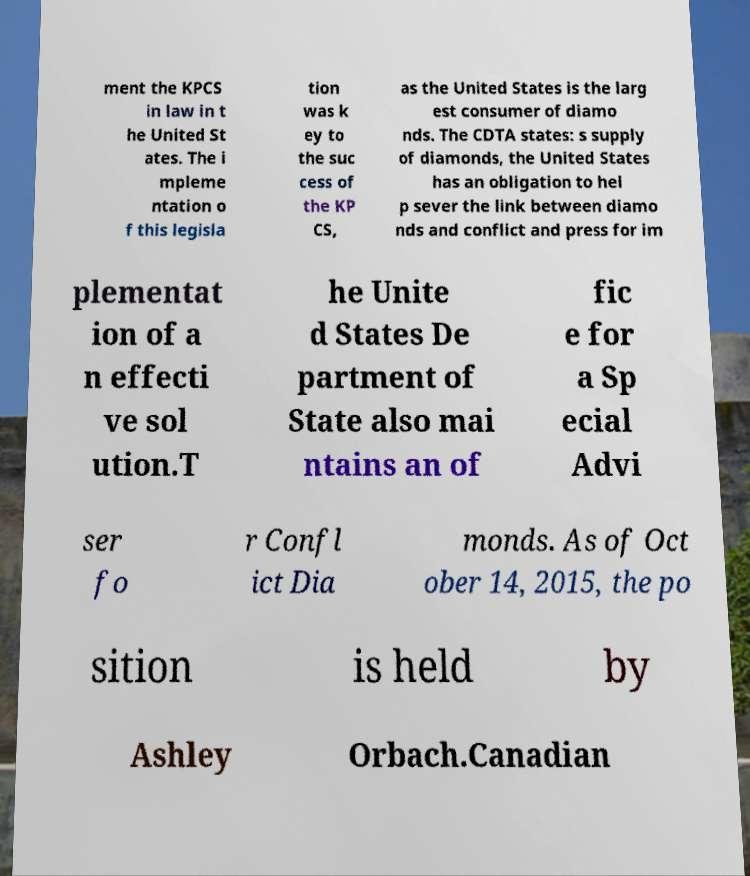Could you extract and type out the text from this image? ment the KPCS in law in t he United St ates. The i mpleme ntation o f this legisla tion was k ey to the suc cess of the KP CS, as the United States is the larg est consumer of diamo nds. The CDTA states: s supply of diamonds, the United States has an obligation to hel p sever the link between diamo nds and conflict and press for im plementat ion of a n effecti ve sol ution.T he Unite d States De partment of State also mai ntains an of fic e for a Sp ecial Advi ser fo r Confl ict Dia monds. As of Oct ober 14, 2015, the po sition is held by Ashley Orbach.Canadian 